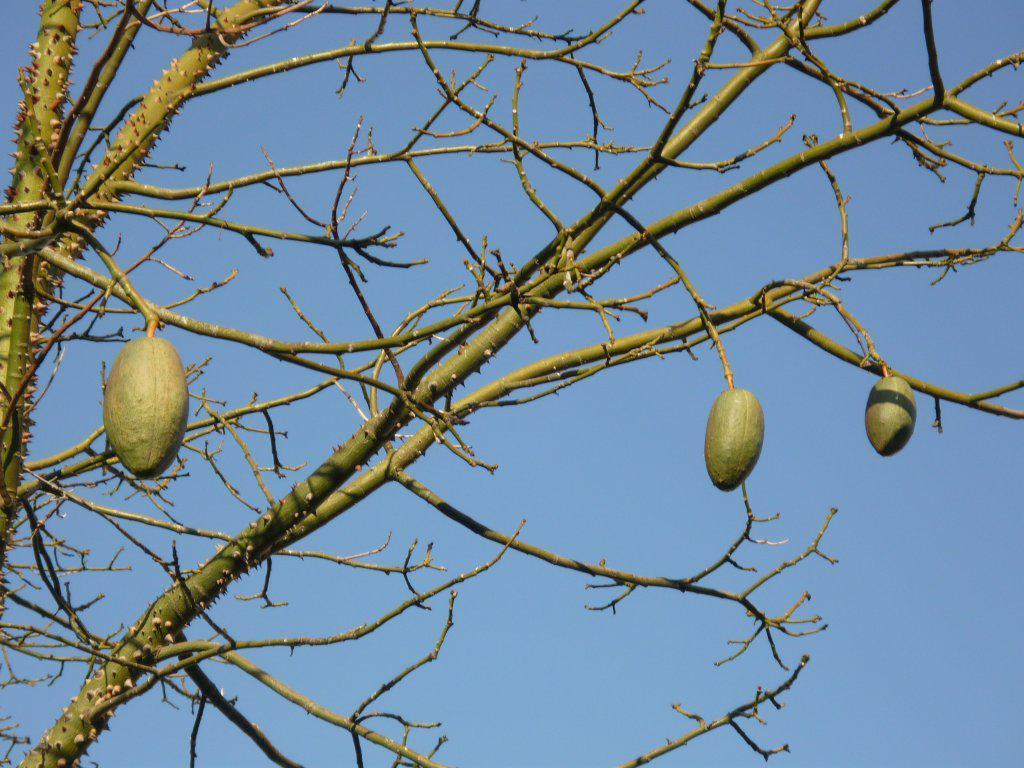What type of food items can be seen in the image? There are fruits in the image. What part of the fruits is visible in the image? There are stems in the image. What else can be seen in the image besides the fruits? There are branches in the image. What is visible in the background of the image? The sky is visible in the background of the image. Can you see any alley, bait, or toes in the image? No, there is no alley, bait, or toes present in the image. 